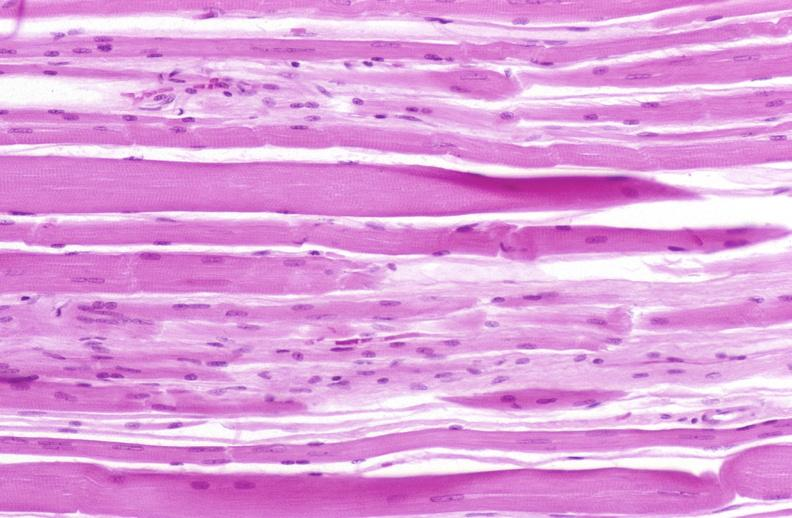does omphalocele show skeletal muscle atrophy?
Answer the question using a single word or phrase. No 